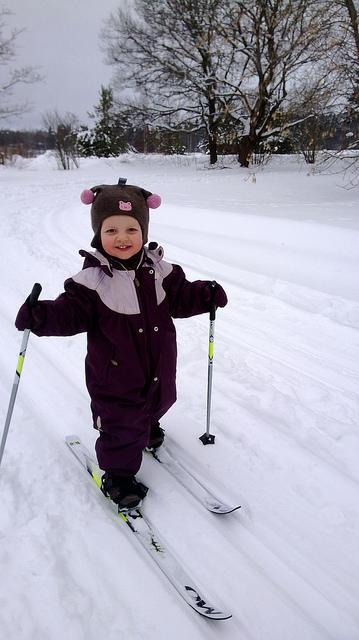What covers the ground?
Keep it brief. Snow. Is the little child having fun?
Give a very brief answer. Yes. Are there poles?
Quick response, please. Yes. 